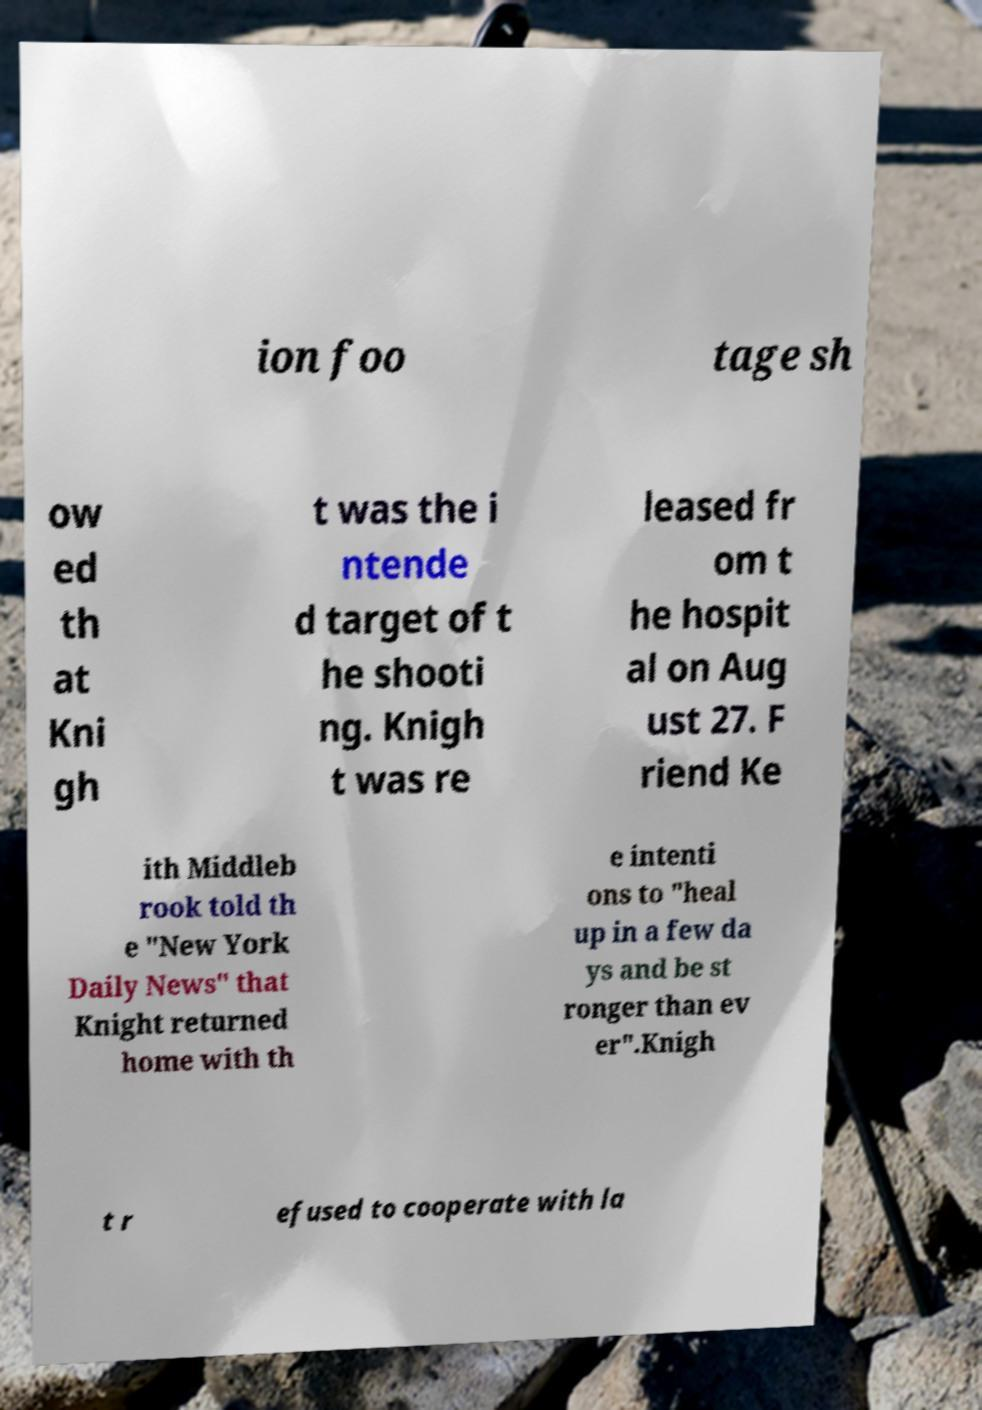There's text embedded in this image that I need extracted. Can you transcribe it verbatim? ion foo tage sh ow ed th at Kni gh t was the i ntende d target of t he shooti ng. Knigh t was re leased fr om t he hospit al on Aug ust 27. F riend Ke ith Middleb rook told th e "New York Daily News" that Knight returned home with th e intenti ons to "heal up in a few da ys and be st ronger than ev er".Knigh t r efused to cooperate with la 